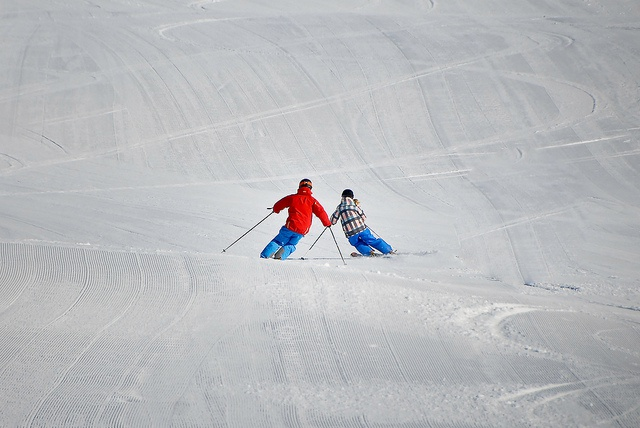Describe the objects in this image and their specific colors. I can see people in darkgray, red, maroon, and blue tones, people in darkgray, lightgray, gray, and blue tones, skis in darkgray, lightgray, and black tones, and skis in darkgray, gray, and lightgray tones in this image. 